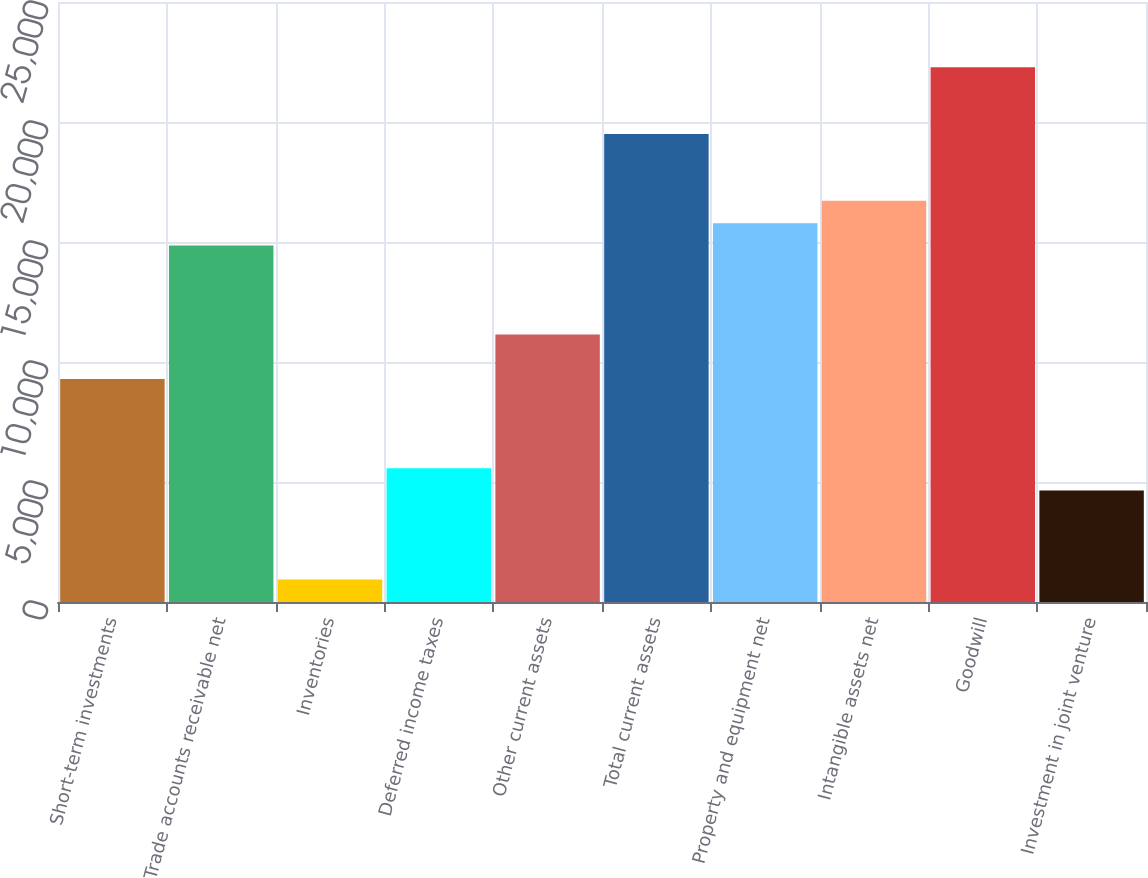Convert chart to OTSL. <chart><loc_0><loc_0><loc_500><loc_500><bar_chart><fcel>Short-term investments<fcel>Trade accounts receivable net<fcel>Inventories<fcel>Deferred income taxes<fcel>Other current assets<fcel>Total current assets<fcel>Property and equipment net<fcel>Intangible assets net<fcel>Goodwill<fcel>Investment in joint venture<nl><fcel>9289<fcel>14857.6<fcel>936.1<fcel>5576.6<fcel>11145.2<fcel>19498.1<fcel>15785.7<fcel>16713.8<fcel>22282.4<fcel>4648.5<nl></chart> 